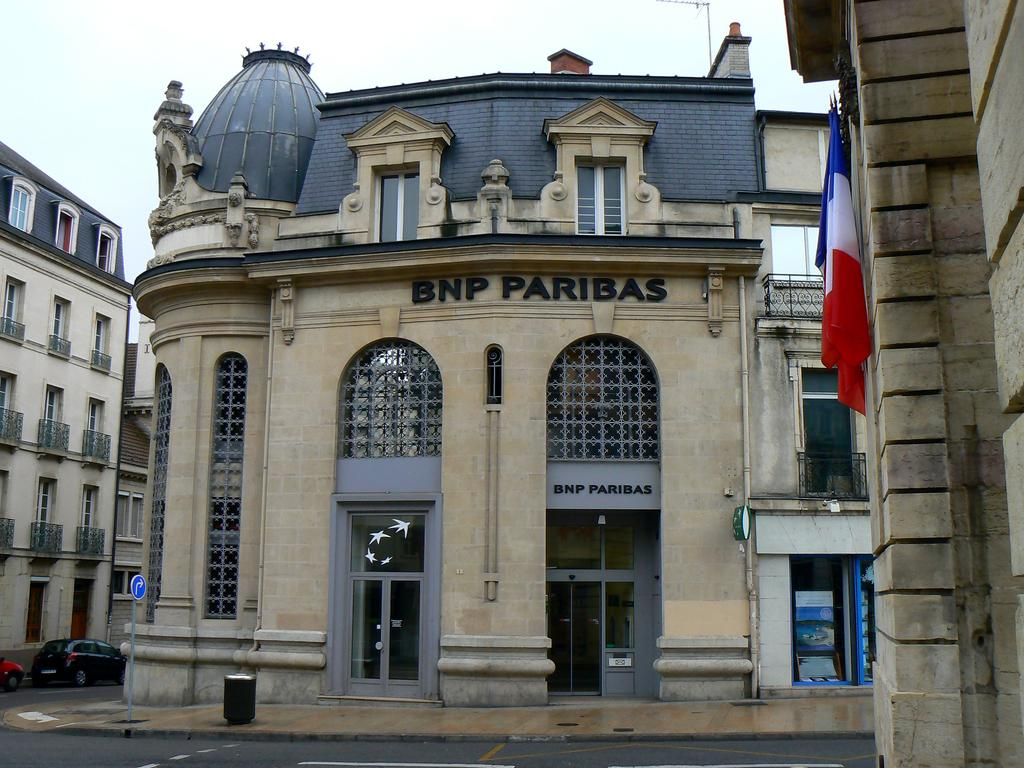What type of structures are present in the image? There are buildings in the image. What feature do the buildings have? The buildings have windows. What can be seen flying in the image? There is a flag in the image. What is used for displaying information in the image? There is a sign board in the image. What mode of transportation is visible in the image? There is a car in the image. Can you tell me how many cushions are on the car in the image? There are no cushions present on the car in the image. What type of fang can be seen in the image? There is no fang present in the image. 